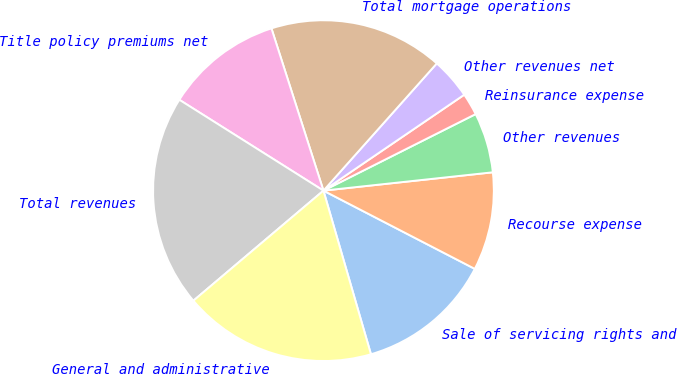Convert chart to OTSL. <chart><loc_0><loc_0><loc_500><loc_500><pie_chart><fcel>Sale of servicing rights and<fcel>Recourse expense<fcel>Other revenues<fcel>Reinsurance expense<fcel>Other revenues net<fcel>Total mortgage operations<fcel>Title policy premiums net<fcel>Total revenues<fcel>General and administrative<nl><fcel>12.91%<fcel>9.31%<fcel>5.7%<fcel>2.1%<fcel>3.9%<fcel>16.52%<fcel>11.11%<fcel>20.13%<fcel>18.32%<nl></chart> 